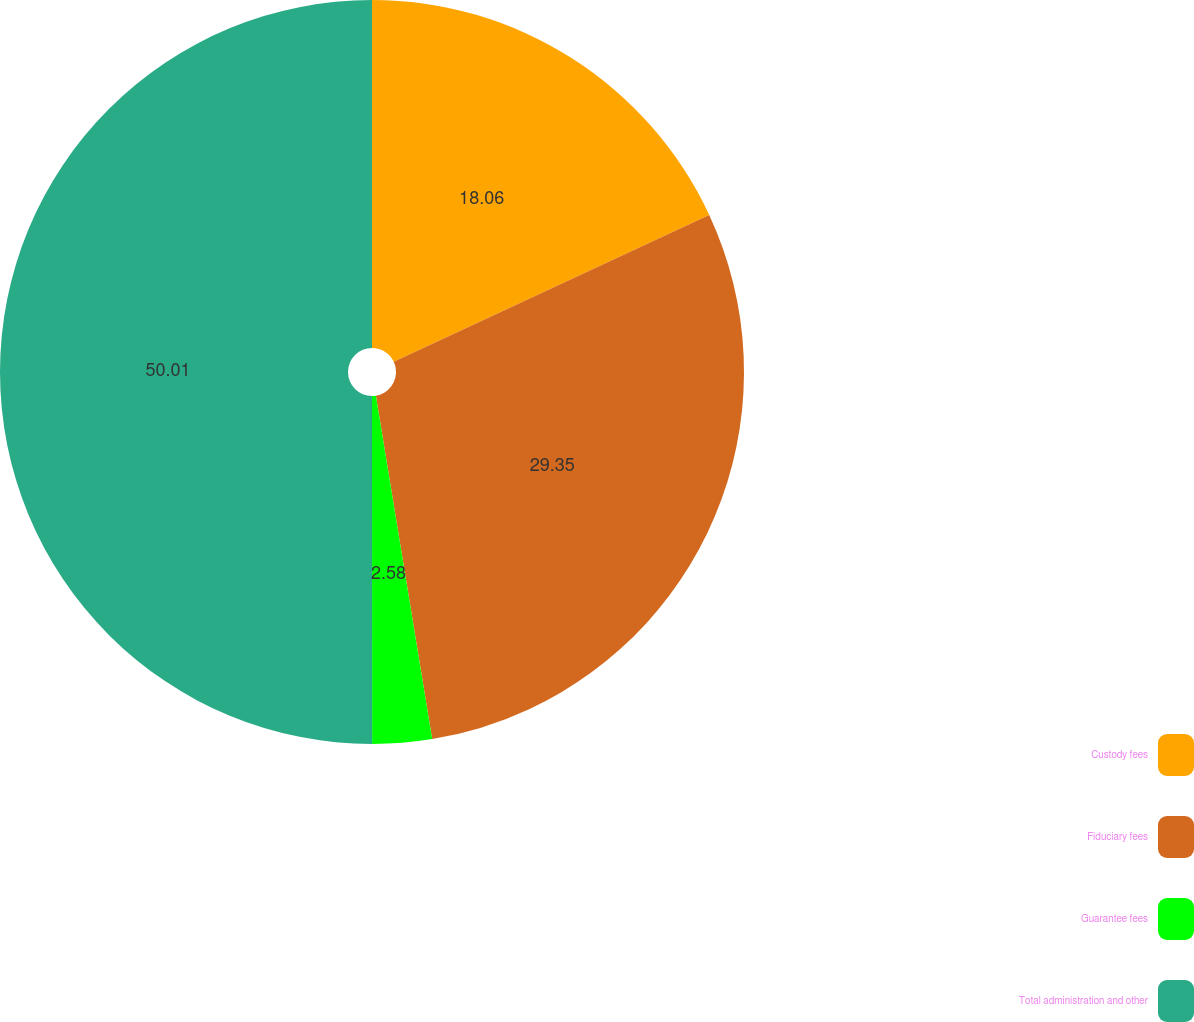Convert chart to OTSL. <chart><loc_0><loc_0><loc_500><loc_500><pie_chart><fcel>Custody fees<fcel>Fiduciary fees<fcel>Guarantee fees<fcel>Total administration and other<nl><fcel>18.06%<fcel>29.35%<fcel>2.58%<fcel>50.0%<nl></chart> 